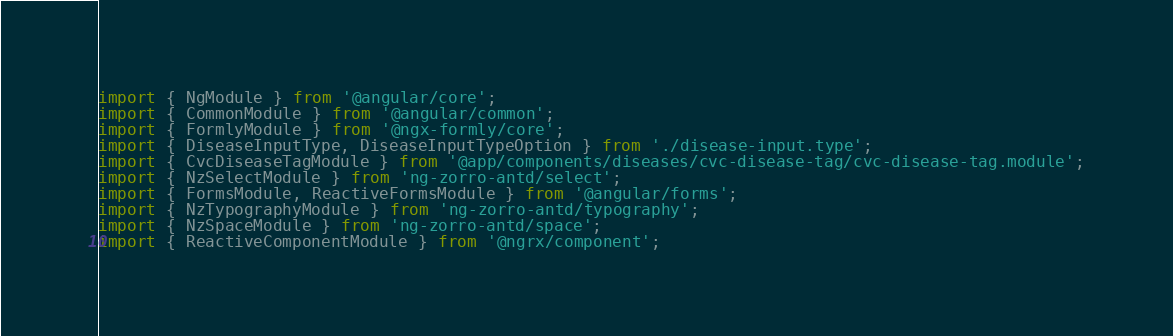<code> <loc_0><loc_0><loc_500><loc_500><_TypeScript_>import { NgModule } from '@angular/core';
import { CommonModule } from '@angular/common';
import { FormlyModule } from '@ngx-formly/core';
import { DiseaseInputType, DiseaseInputTypeOption } from './disease-input.type';
import { CvcDiseaseTagModule } from '@app/components/diseases/cvc-disease-tag/cvc-disease-tag.module';
import { NzSelectModule } from 'ng-zorro-antd/select';
import { FormsModule, ReactiveFormsModule } from '@angular/forms';
import { NzTypographyModule } from 'ng-zorro-antd/typography';
import { NzSpaceModule } from 'ng-zorro-antd/space';
import { ReactiveComponentModule } from '@ngrx/component';</code> 